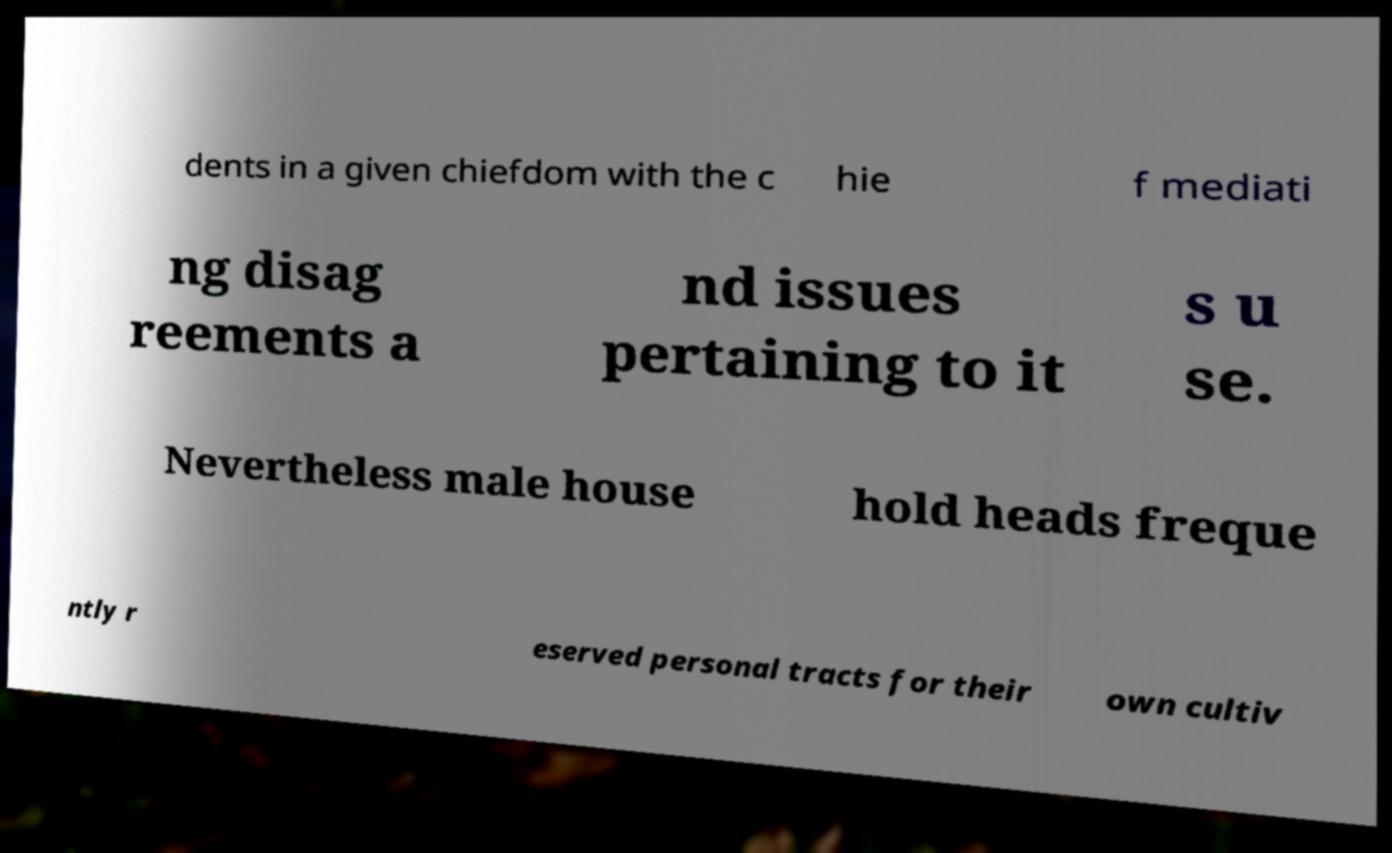What messages or text are displayed in this image? I need them in a readable, typed format. dents in a given chiefdom with the c hie f mediati ng disag reements a nd issues pertaining to it s u se. Nevertheless male house hold heads freque ntly r eserved personal tracts for their own cultiv 